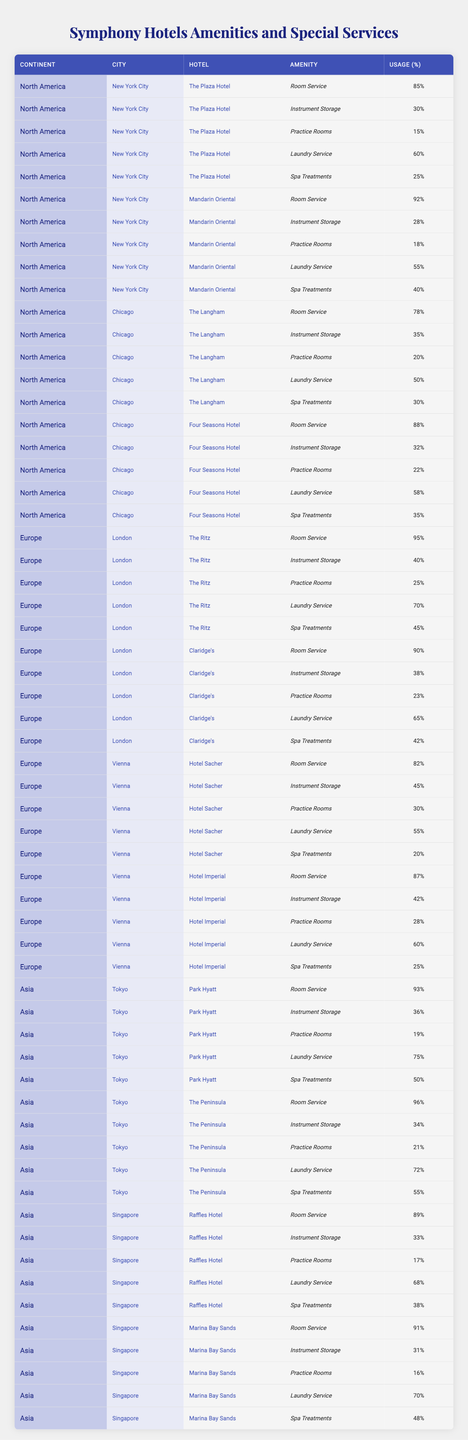What hotel in New York City has the highest usage of room service by symphony members? The table shows that in New York City, the Mandarin Oriental has the highest usage of room service at 92%.
Answer: 92% Which hotel in London has a higher usage of practice rooms, The Ritz or Claridge's? The table indicates that The Ritz has 25% usage of practice rooms, while Claridge's has 23%. Therefore, The Ritz has a higher usage.
Answer: The Ritz What is the total usage percentage of laundry service for hotels in Chicago? In Chicago, the usage percentages for laundry service are as follows: The Langham (50%) and Four Seasons Hotel (58%). Adding these gives 50 + 58 = 108%.
Answer: 108% Do symphony members use spa treatments more in Europe than in Asia? In Europe, the highest usage of spa treatments is at The Ritz with 45%, while in Asia, The Peninsula has 55%. Since 55% is greater than 45%, the usage is higher in Asia.
Answer: Yes What percentage of symphony members utilized instrument storage at the Hotel Sacher in Vienna? The table shows that the Hotel Sacher has 45% usage of instrument storage by symphony members.
Answer: 45% Which city has the highest average usage of room service among the hotels listed? The room service usage percentages are: New York City average is (85 + 92) / 2 = 88.5%, Chicago average is (78 + 88) / 2 = 83%, London average is (95 + 90) / 2 = 92.5%, Vienna average is (82 + 87) / 2 = 84.5%, Tokyo average is (93 + 96) / 2 = 94.5%, and Singapore average is (89 + 91) / 2 = 90%. The highest average is 94.5% for Tokyo.
Answer: Tokyo How many hotels in Asia have a laundry service usage percentage above 70%? In the table, Park Hyatt has 75% and The Peninsula has 72%. Both are above 70%, totaling 2 hotels.
Answer: 2 hotels Is the usage of practice rooms higher in hotels located in North America compared to those in Europe? In North America, The Plaza has 15% and Mandarin has 18% (average = 16.5%); in Europe, The Ritz has 25% and Claridge's has 23% (average = 24%). Since 24% is higher than 16.5%, usage is higher in Europe.
Answer: No What is the difference in usage percentage of laundry service between the hotels in New York City and those in Chicago? In New York City, usage is (60 + 55) / 2 = 57.5%, and in Chicago, it is (50 + 58) / 2 = 54%. The difference is 57.5 - 54 = 3.5%.
Answer: 3.5% Which hotel offers the most spa treatments in Asia? The table lists spa treatment usage for Park Hyatt at 50% and The Peninsula at 55%. The Peninsula has the highest percentage at 55%.
Answer: The Peninsula Are there any hotels in Vienna that have a usage percentage for room service below 85%? The Hotel Sacher has 82% room service usage, which is below 85%. Hotel Imperial has 87%, which is above. Thus, there is one hotel below 85%.
Answer: Yes 